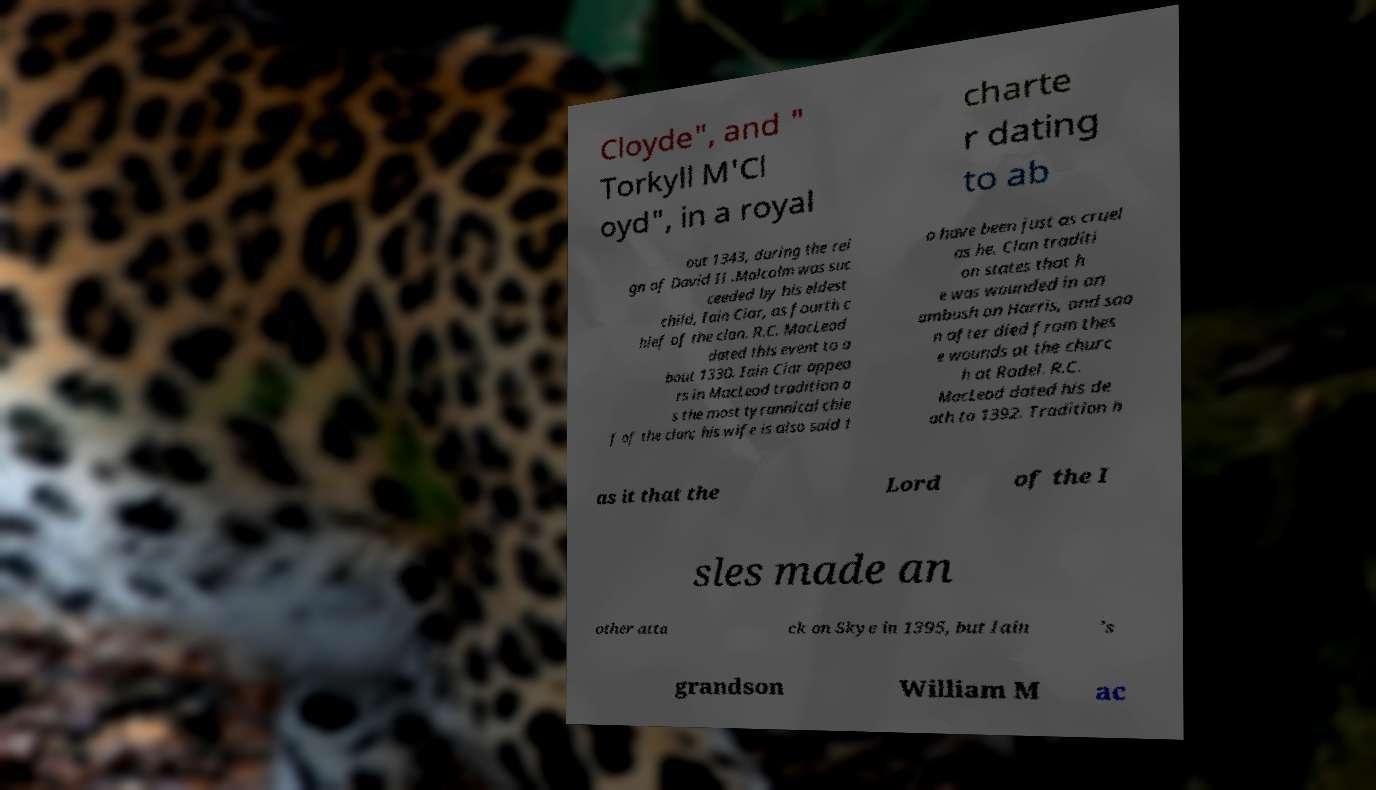I need the written content from this picture converted into text. Can you do that? Cloyde", and " Torkyll M'Cl oyd", in a royal charte r dating to ab out 1343, during the rei gn of David II .Malcolm was suc ceeded by his eldest child, Iain Ciar, as fourth c hief of the clan. R.C. MacLeod dated this event to a bout 1330. Iain Ciar appea rs in MacLeod tradition a s the most tyrannical chie f of the clan; his wife is also said t o have been just as cruel as he. Clan traditi on states that h e was wounded in an ambush on Harris, and soo n after died from thes e wounds at the churc h at Rodel. R.C. MacLeod dated his de ath to 1392. Tradition h as it that the Lord of the I sles made an other atta ck on Skye in 1395, but Iain 's grandson William M ac 